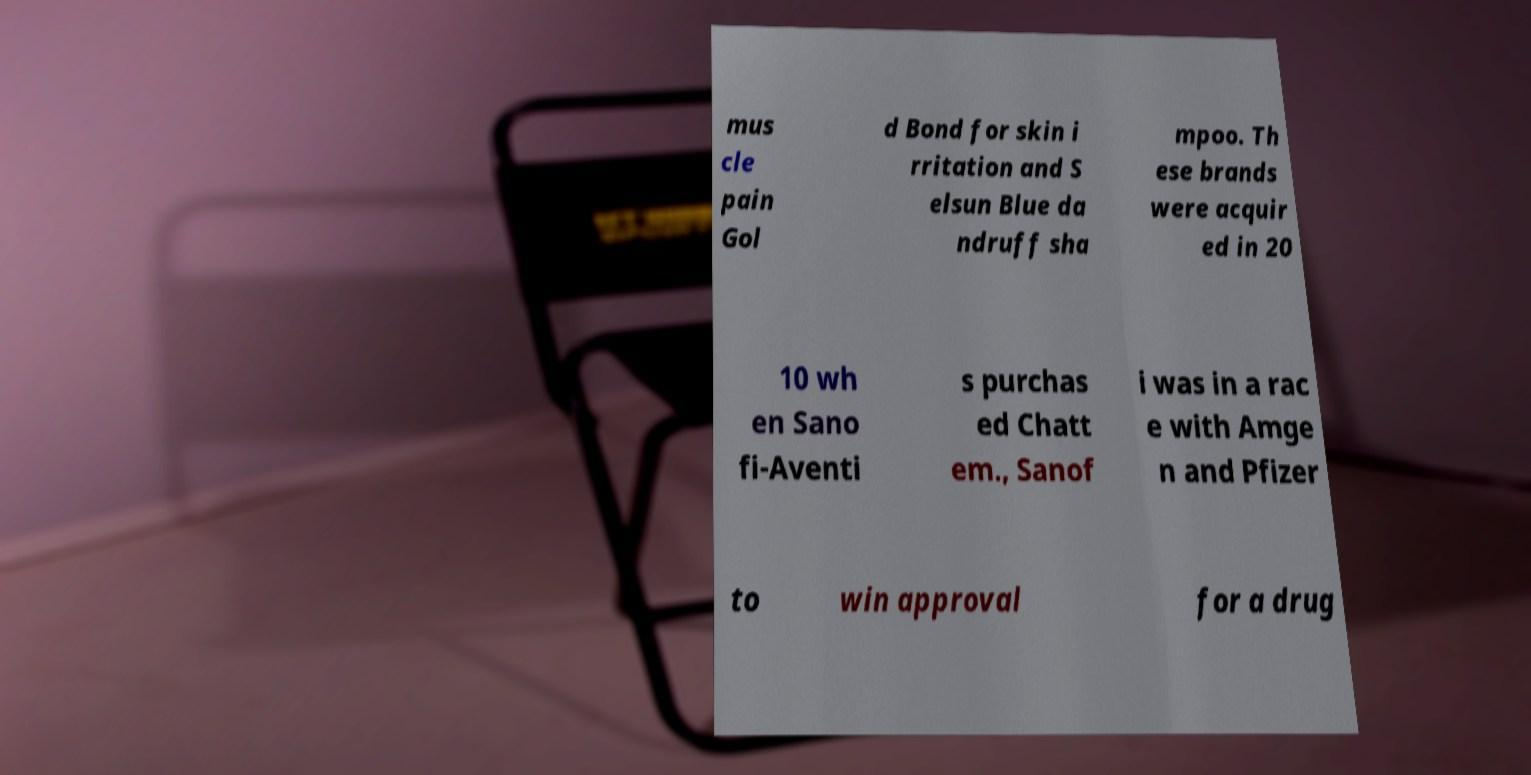Can you accurately transcribe the text from the provided image for me? mus cle pain Gol d Bond for skin i rritation and S elsun Blue da ndruff sha mpoo. Th ese brands were acquir ed in 20 10 wh en Sano fi-Aventi s purchas ed Chatt em., Sanof i was in a rac e with Amge n and Pfizer to win approval for a drug 